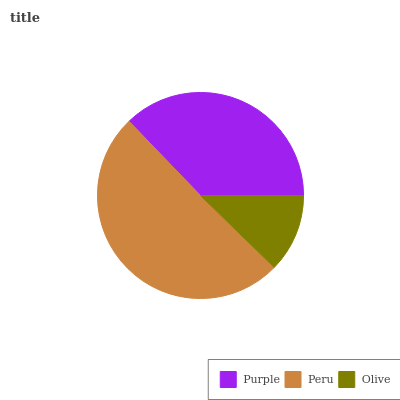Is Olive the minimum?
Answer yes or no. Yes. Is Peru the maximum?
Answer yes or no. Yes. Is Peru the minimum?
Answer yes or no. No. Is Olive the maximum?
Answer yes or no. No. Is Peru greater than Olive?
Answer yes or no. Yes. Is Olive less than Peru?
Answer yes or no. Yes. Is Olive greater than Peru?
Answer yes or no. No. Is Peru less than Olive?
Answer yes or no. No. Is Purple the high median?
Answer yes or no. Yes. Is Purple the low median?
Answer yes or no. Yes. Is Peru the high median?
Answer yes or no. No. Is Peru the low median?
Answer yes or no. No. 